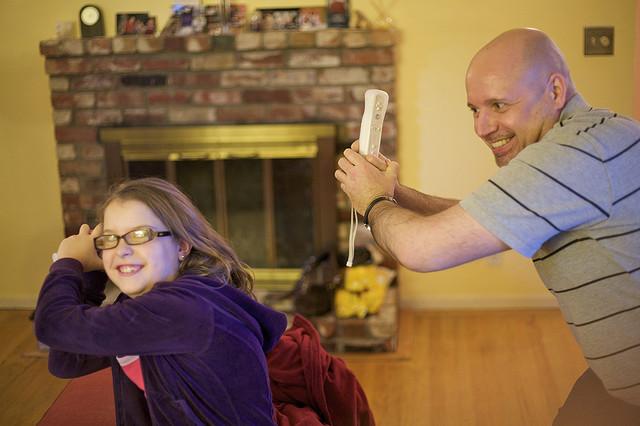Has this guy recently shaved?
Give a very brief answer. Yes. What color is the girl's jacket?
Answer briefly. Purple. Who is wearing glasses?
Keep it brief. Girl. What gaming system is being played?
Keep it brief. Wii. Are these prizes?
Keep it brief. No. 